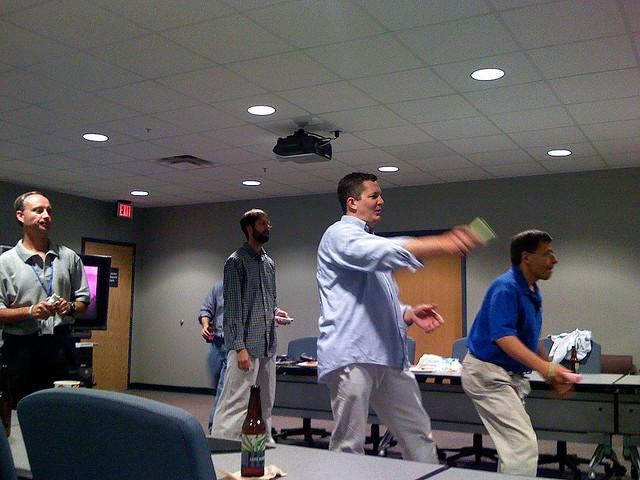What is everyone doing standing with remotes? Please explain your reasoning. video gaming. People are gaming. 